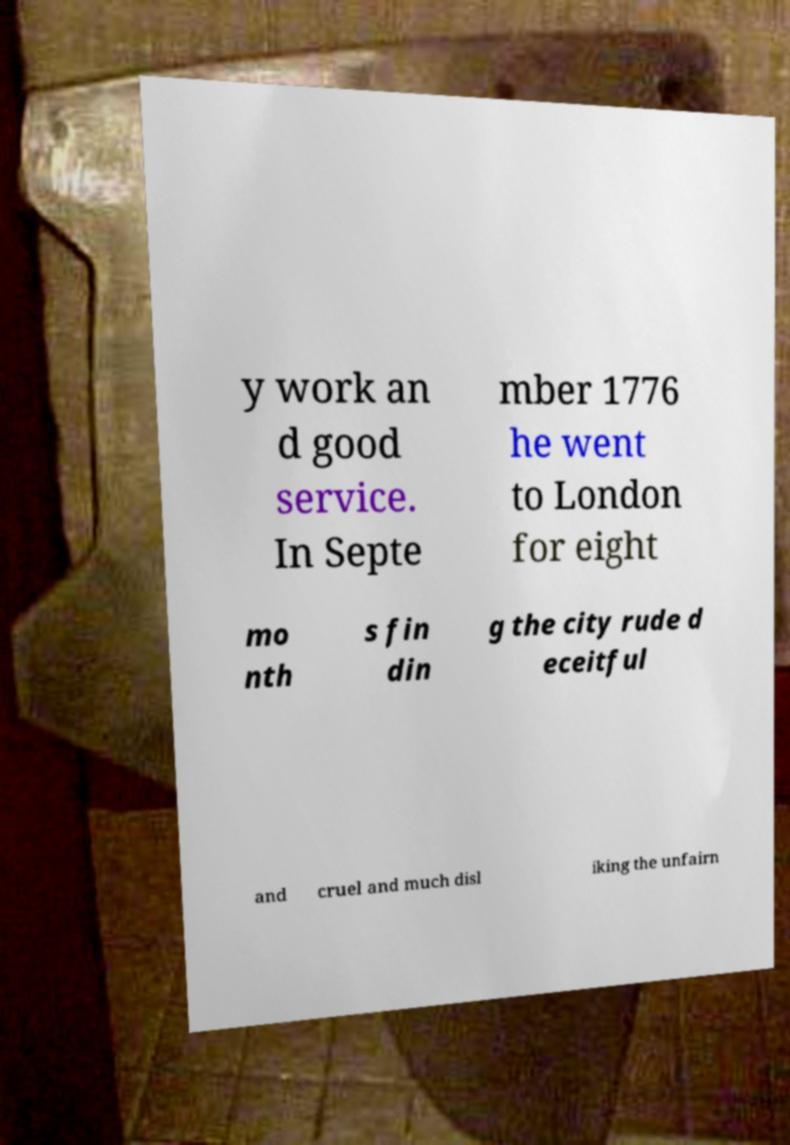Can you accurately transcribe the text from the provided image for me? y work an d good service. In Septe mber 1776 he went to London for eight mo nth s fin din g the city rude d eceitful and cruel and much disl iking the unfairn 